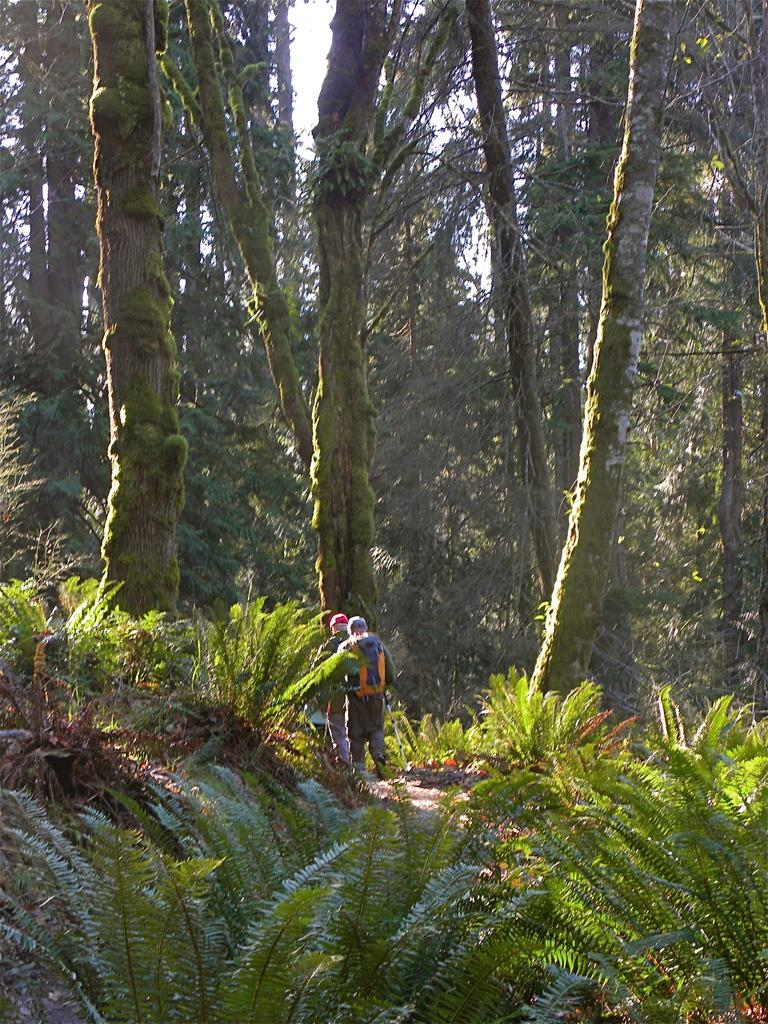How many people are in the image? There are two persons walking in the image. What can be seen in the background of the image? There are trees in the background of the image. What is the color of the trees? The trees are green in color. What is visible above the trees in the image? The sky is visible in the image. What is the color of the sky? The sky is white in color. What type of weather can be seen in the image? There is no specific weather condition visible in the image. The image only shows two persons walking, trees in the background, and a white sky. Weather conditions are not mentioned in the provided facts. 